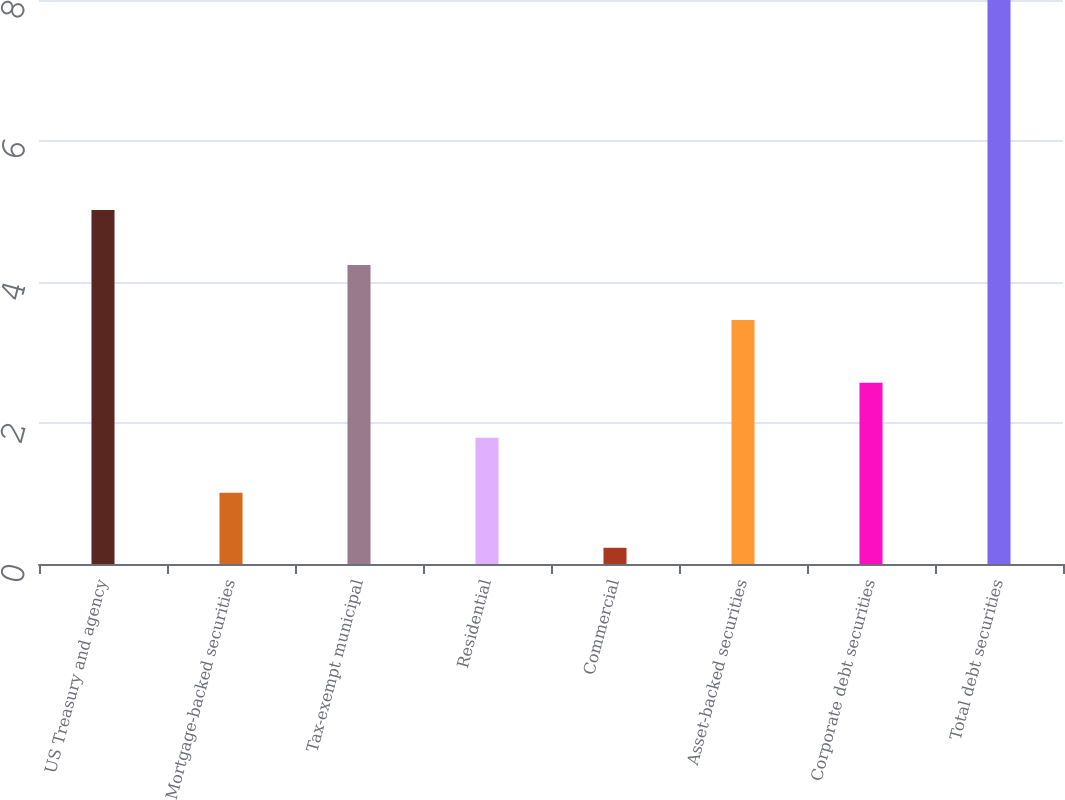<chart> <loc_0><loc_0><loc_500><loc_500><bar_chart><fcel>US Treasury and agency<fcel>Mortgage-backed securities<fcel>Tax-exempt municipal<fcel>Residential<fcel>Commercial<fcel>Asset-backed securities<fcel>Corporate debt securities<fcel>Total debt securities<nl><fcel>5.02<fcel>1.01<fcel>4.24<fcel>1.79<fcel>0.23<fcel>3.46<fcel>2.57<fcel>8<nl></chart> 